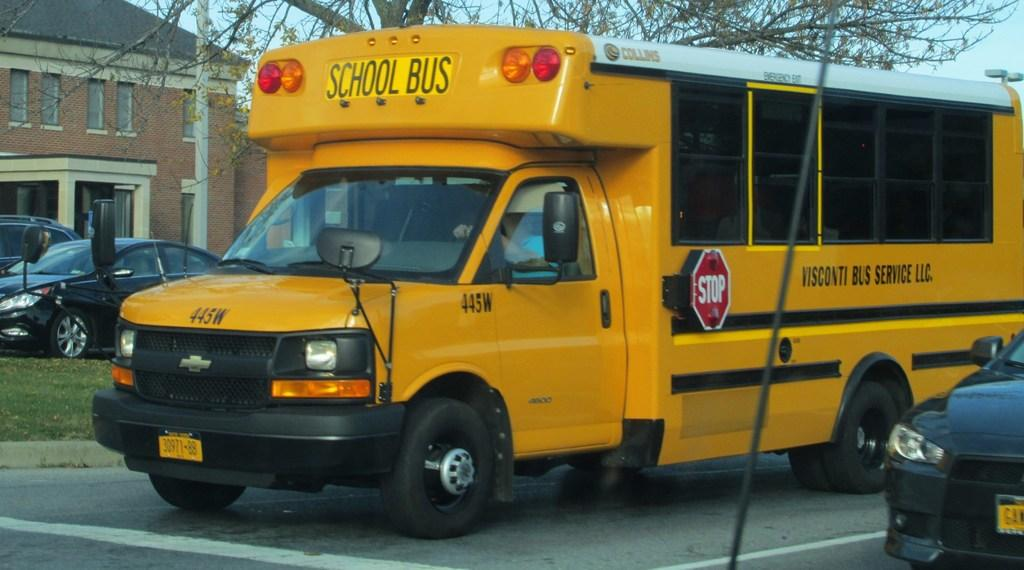Provide a one-sentence caption for the provided image. Yellow school bus with a black car parked beside it. 